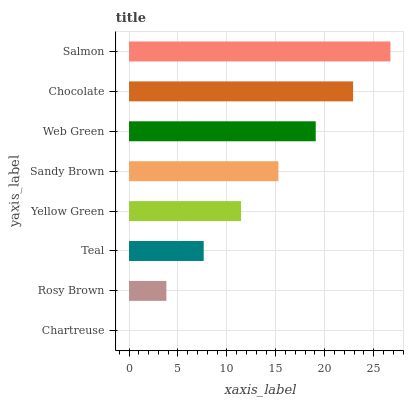Is Chartreuse the minimum?
Answer yes or no. Yes. Is Salmon the maximum?
Answer yes or no. Yes. Is Rosy Brown the minimum?
Answer yes or no. No. Is Rosy Brown the maximum?
Answer yes or no. No. Is Rosy Brown greater than Chartreuse?
Answer yes or no. Yes. Is Chartreuse less than Rosy Brown?
Answer yes or no. Yes. Is Chartreuse greater than Rosy Brown?
Answer yes or no. No. Is Rosy Brown less than Chartreuse?
Answer yes or no. No. Is Sandy Brown the high median?
Answer yes or no. Yes. Is Yellow Green the low median?
Answer yes or no. Yes. Is Rosy Brown the high median?
Answer yes or no. No. Is Web Green the low median?
Answer yes or no. No. 